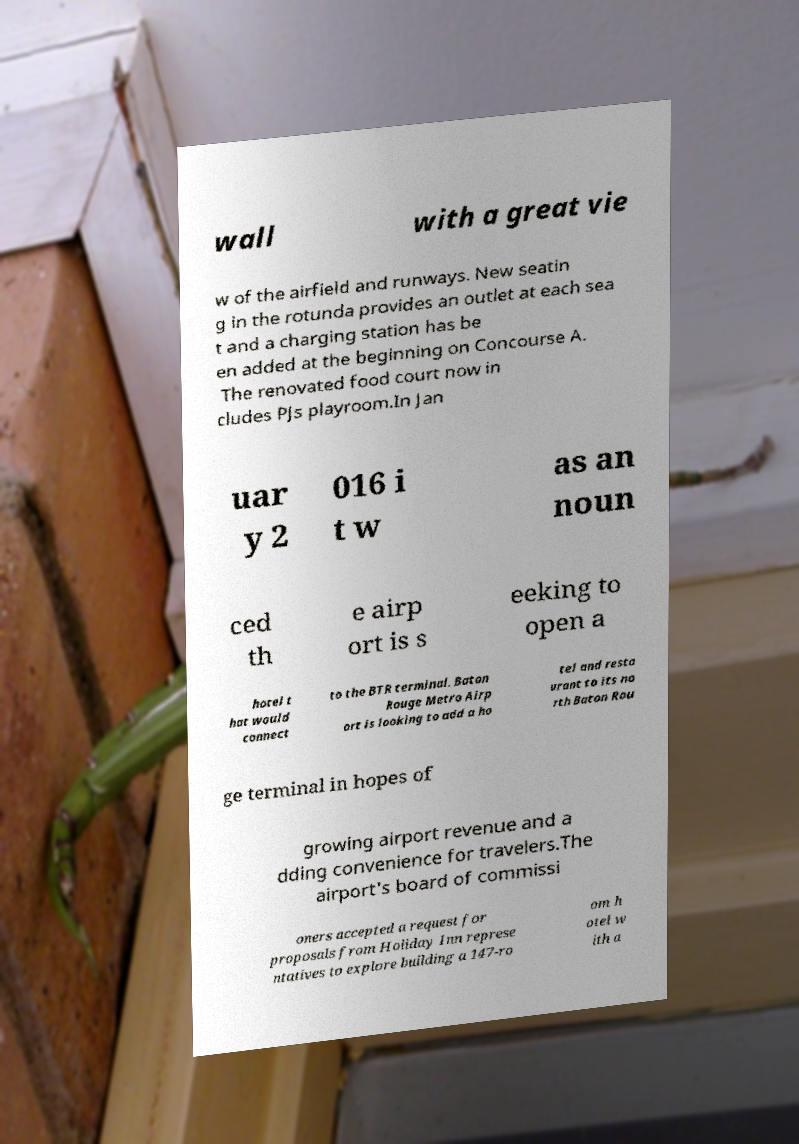Please identify and transcribe the text found in this image. wall with a great vie w of the airfield and runways. New seatin g in the rotunda provides an outlet at each sea t and a charging station has be en added at the beginning on Concourse A. The renovated food court now in cludes PJs playroom.In Jan uar y 2 016 i t w as an noun ced th e airp ort is s eeking to open a hotel t hat would connect to the BTR terminal. Baton Rouge Metro Airp ort is looking to add a ho tel and resta urant to its no rth Baton Rou ge terminal in hopes of growing airport revenue and a dding convenience for travelers.The airport's board of commissi oners accepted a request for proposals from Holiday Inn represe ntatives to explore building a 147-ro om h otel w ith a 